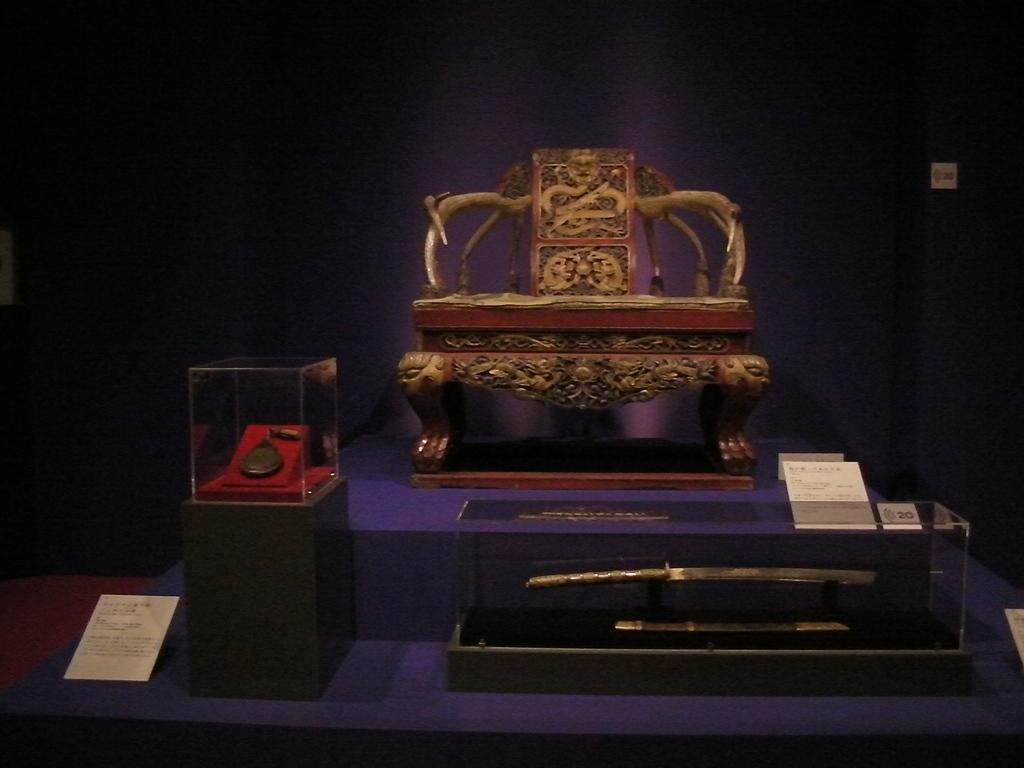What type of weapon is present in the image? There is a sword in the image. What type of award or recognition is depicted in the image? There is a medal in the image. How is the chair positioned in the image? The chair is on a table in the image. What can be seen behind the table in the image? The table is placed in front of a wall in the background of the image. Can you see a river flowing behind the wall in the image? There is no river visible in the image; it only shows a sword, a medal, a chair on a table, and a wall in the background. 